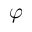<formula> <loc_0><loc_0><loc_500><loc_500>\varphi</formula> 